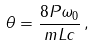<formula> <loc_0><loc_0><loc_500><loc_500>\theta = \frac { 8 P \omega _ { 0 } } { m L c } \, ,</formula> 